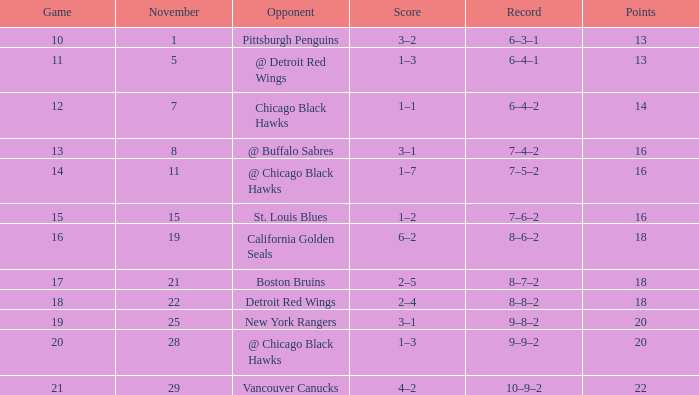What record has a november greater than 11, and st. louis blues as the opponent? 7–6–2. 